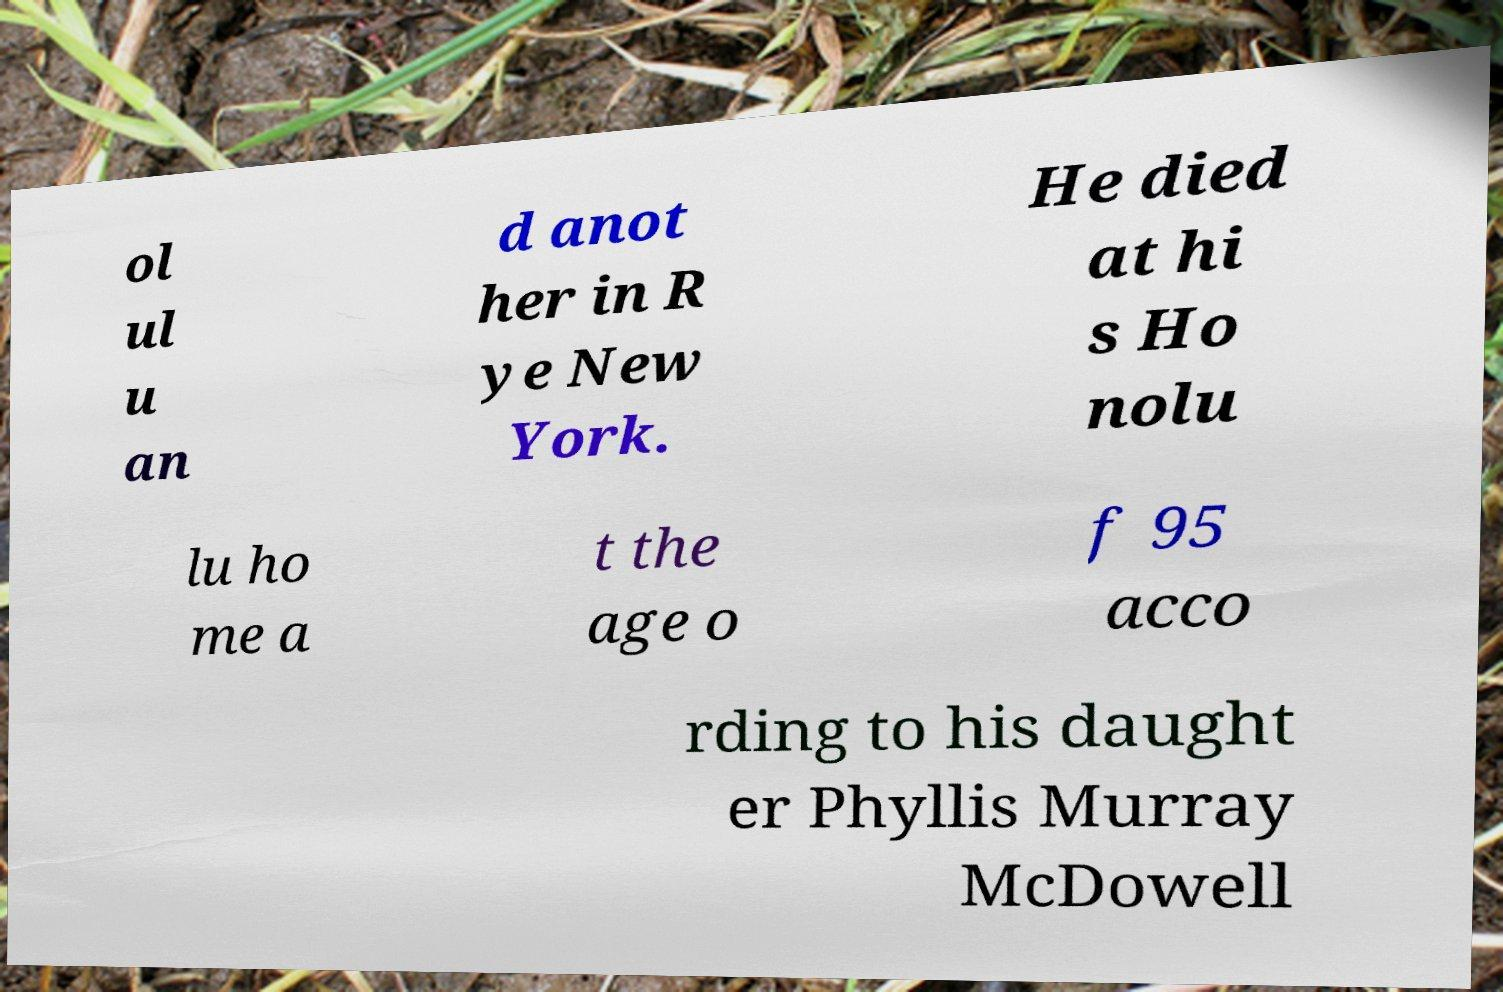For documentation purposes, I need the text within this image transcribed. Could you provide that? ol ul u an d anot her in R ye New York. He died at hi s Ho nolu lu ho me a t the age o f 95 acco rding to his daught er Phyllis Murray McDowell 